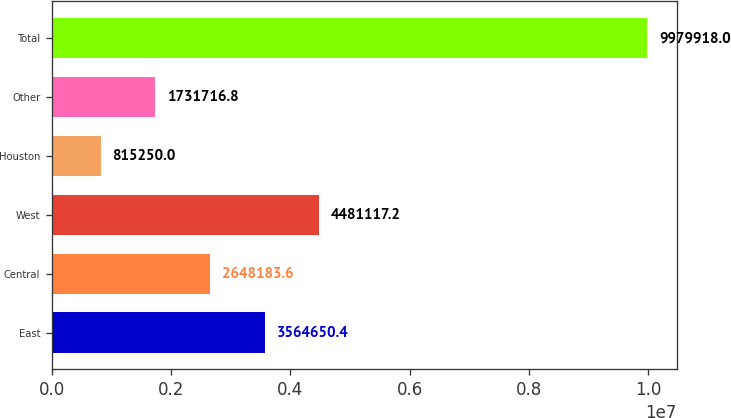Convert chart. <chart><loc_0><loc_0><loc_500><loc_500><bar_chart><fcel>East<fcel>Central<fcel>West<fcel>Houston<fcel>Other<fcel>Total<nl><fcel>3.56465e+06<fcel>2.64818e+06<fcel>4.48112e+06<fcel>815250<fcel>1.73172e+06<fcel>9.97992e+06<nl></chart> 